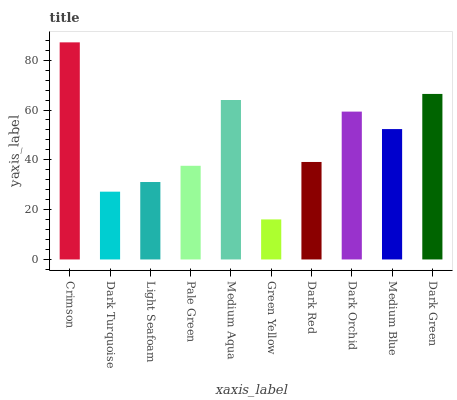Is Green Yellow the minimum?
Answer yes or no. Yes. Is Crimson the maximum?
Answer yes or no. Yes. Is Dark Turquoise the minimum?
Answer yes or no. No. Is Dark Turquoise the maximum?
Answer yes or no. No. Is Crimson greater than Dark Turquoise?
Answer yes or no. Yes. Is Dark Turquoise less than Crimson?
Answer yes or no. Yes. Is Dark Turquoise greater than Crimson?
Answer yes or no. No. Is Crimson less than Dark Turquoise?
Answer yes or no. No. Is Medium Blue the high median?
Answer yes or no. Yes. Is Dark Red the low median?
Answer yes or no. Yes. Is Dark Orchid the high median?
Answer yes or no. No. Is Pale Green the low median?
Answer yes or no. No. 